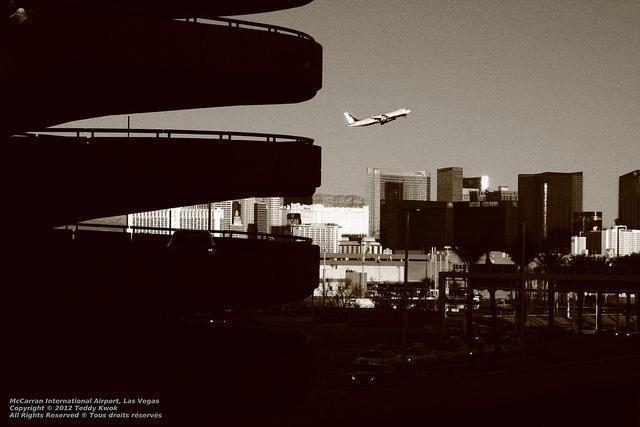What is taking off?
From the following four choices, select the correct answer to address the question.
Options: Airplane, balloon, helicopter, kite. Airplane. 